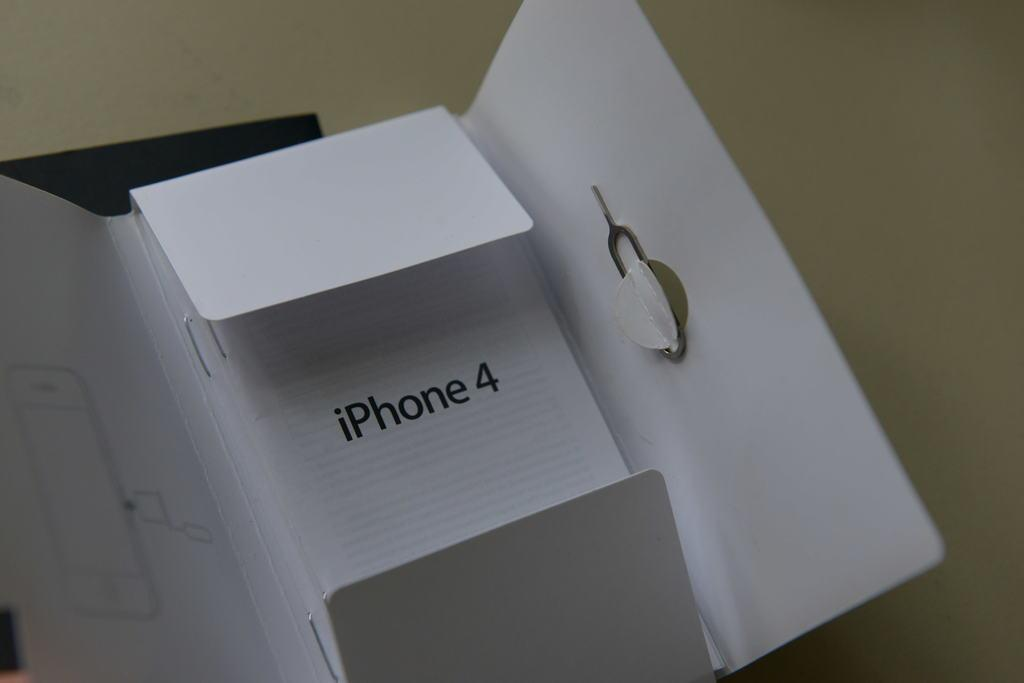<image>
Present a compact description of the photo's key features. The packaging of an iPhone 4  is shown empty. 